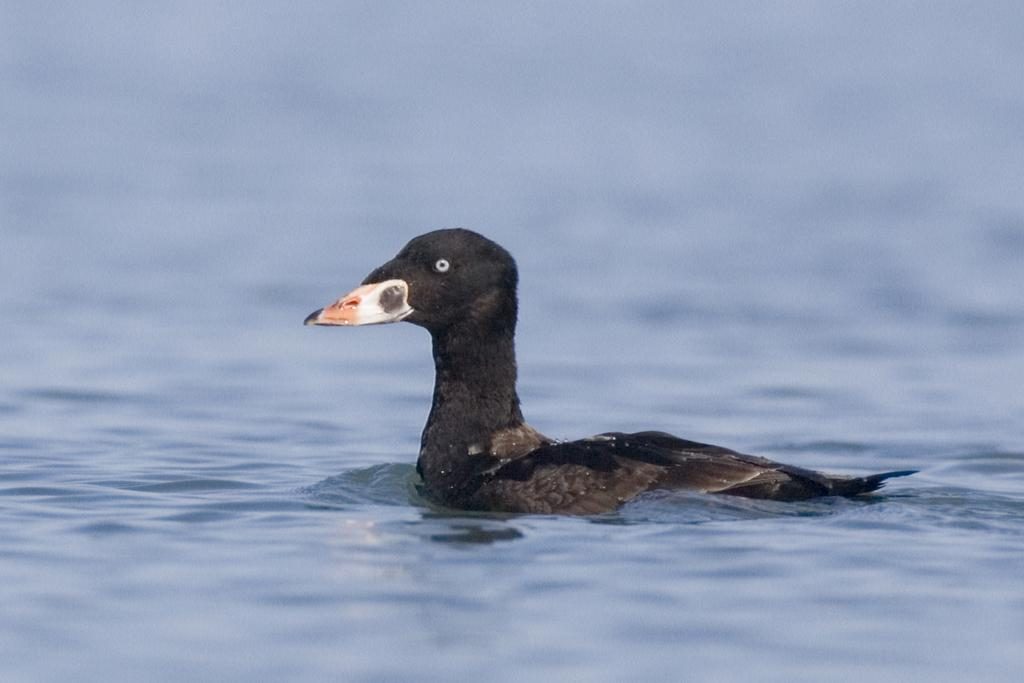What type of animal can be seen in the image? There is a bird in the image. Where is the bird located in the image? The bird is on the surface of water. What type of team is the bird a part of in the image? There is no indication of a team in the image, as it features a bird on the surface of water. 